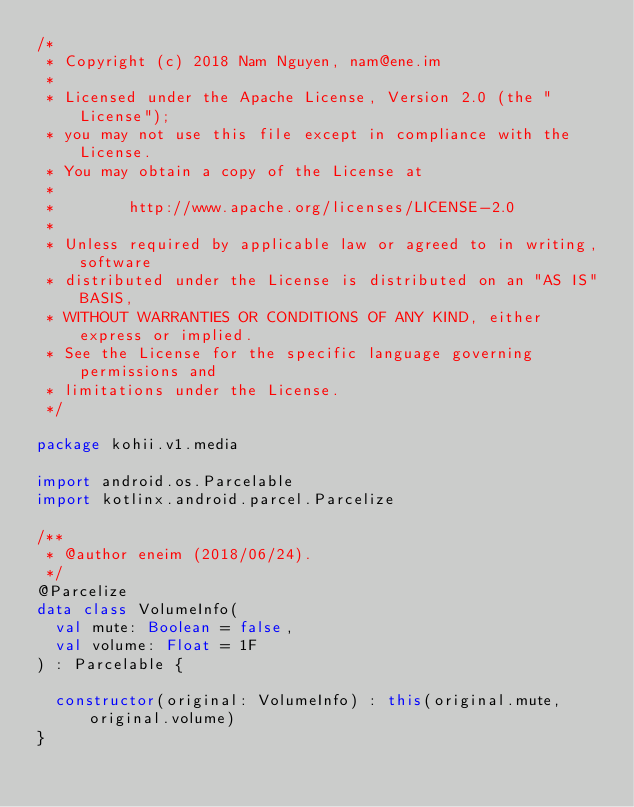Convert code to text. <code><loc_0><loc_0><loc_500><loc_500><_Kotlin_>/*
 * Copyright (c) 2018 Nam Nguyen, nam@ene.im
 *
 * Licensed under the Apache License, Version 2.0 (the "License");
 * you may not use this file except in compliance with the License.
 * You may obtain a copy of the License at
 *
 *        http://www.apache.org/licenses/LICENSE-2.0
 *
 * Unless required by applicable law or agreed to in writing, software
 * distributed under the License is distributed on an "AS IS" BASIS,
 * WITHOUT WARRANTIES OR CONDITIONS OF ANY KIND, either express or implied.
 * See the License for the specific language governing permissions and
 * limitations under the License.
 */

package kohii.v1.media

import android.os.Parcelable
import kotlinx.android.parcel.Parcelize

/**
 * @author eneim (2018/06/24).
 */
@Parcelize
data class VolumeInfo(
  val mute: Boolean = false,
  val volume: Float = 1F
) : Parcelable {

  constructor(original: VolumeInfo) : this(original.mute, original.volume)
}
</code> 